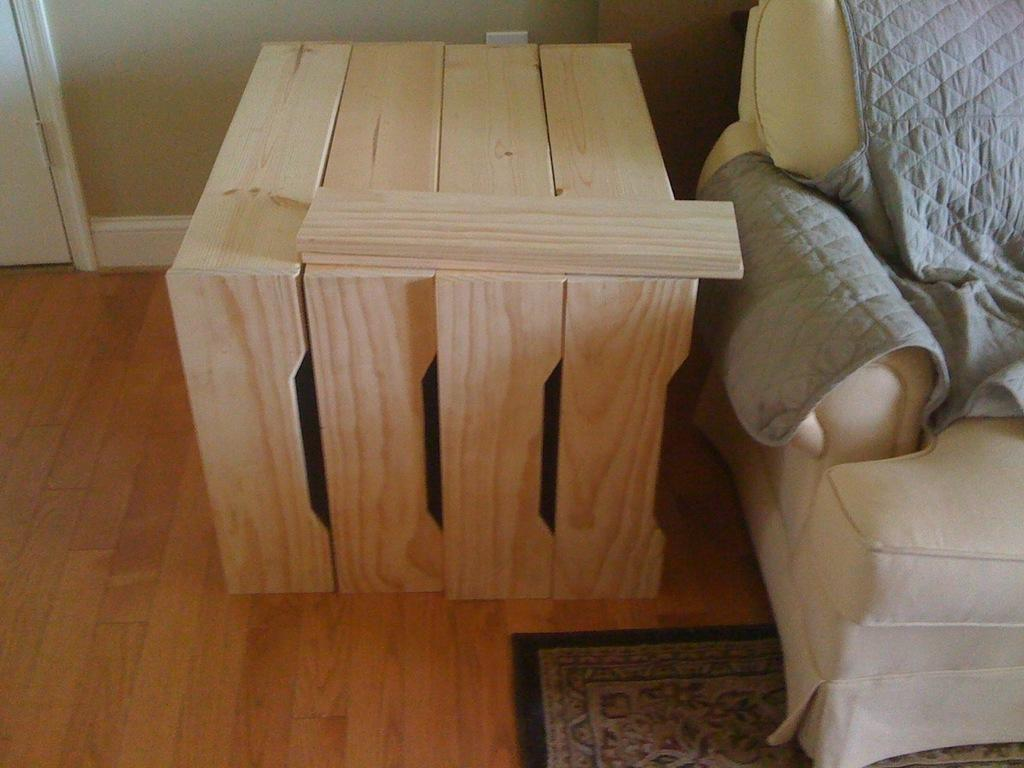What type of wooden object is visible in the image? There is a wooden object in the image, but the specific type is not mentioned in the facts. What type of furniture is present in the image? There is a sofa in the image. What can be seen in the background of the image? There is a wall in the background of the image. Is there any entrance or exit visible in the image? Yes, there is a door beside the wall in the image. What type of pleasure can be seen being rewarded with good health in the image? There is no indication of pleasure, reward, or health in the image; it only features a wooden object, a sofa, a wall, and a door. 